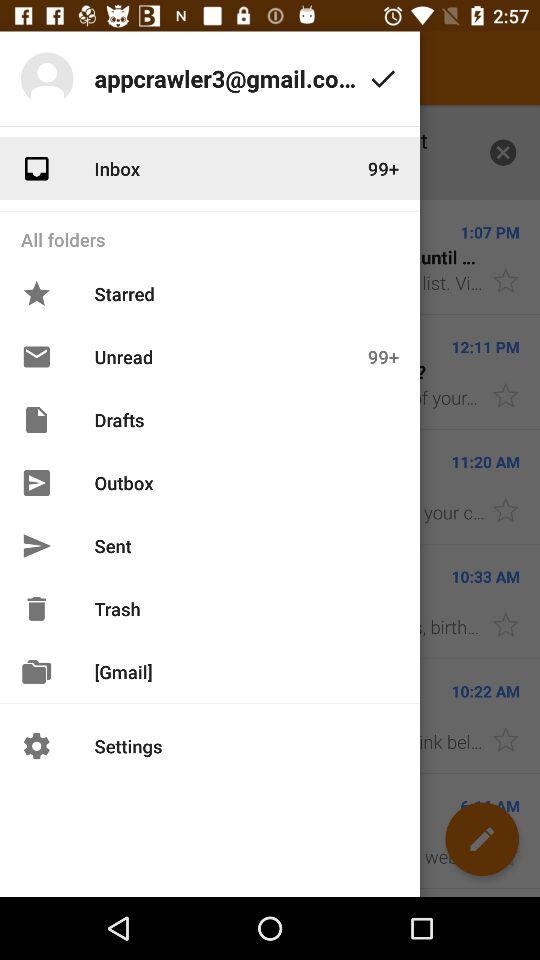How many emails are there in "Sent"?
When the provided information is insufficient, respond with <no answer>. <no answer> 